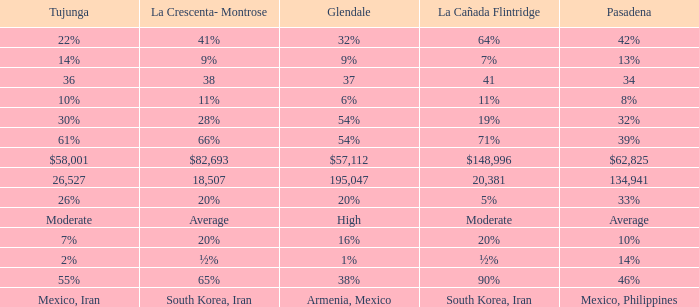When Pasadena is at 10%, what is La Crescenta-Montrose? 20%. 